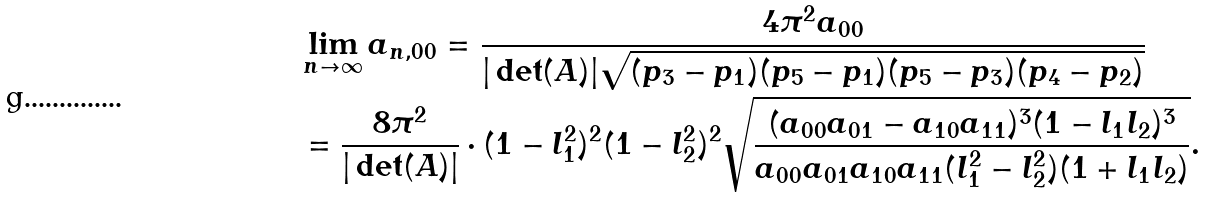<formula> <loc_0><loc_0><loc_500><loc_500>& \lim _ { n \to \infty } a _ { n , 0 0 } = \frac { 4 \pi ^ { 2 } a _ { 0 0 } } { | \det ( A ) | \sqrt { ( p _ { 3 } - p _ { 1 } ) ( p _ { 5 } - p _ { 1 } ) ( p _ { 5 } - p _ { 3 } ) ( p _ { 4 } - p _ { 2 } ) } } \\ & = \frac { 8 \pi ^ { 2 } } { | \det ( A ) | } \cdot ( 1 - l _ { 1 } ^ { 2 } ) ^ { 2 } ( 1 - l _ { 2 } ^ { 2 } ) ^ { 2 } \sqrt { \frac { ( a _ { 0 0 } a _ { 0 1 } - a _ { 1 0 } a _ { 1 1 } ) ^ { 3 } ( 1 - l _ { 1 } l _ { 2 } ) ^ { 3 } } { a _ { 0 0 } a _ { 0 1 } a _ { 1 0 } a _ { 1 1 } ( l _ { 1 } ^ { 2 } - l _ { 2 } ^ { 2 } ) ( 1 + l _ { 1 } l _ { 2 } ) } } .</formula> 